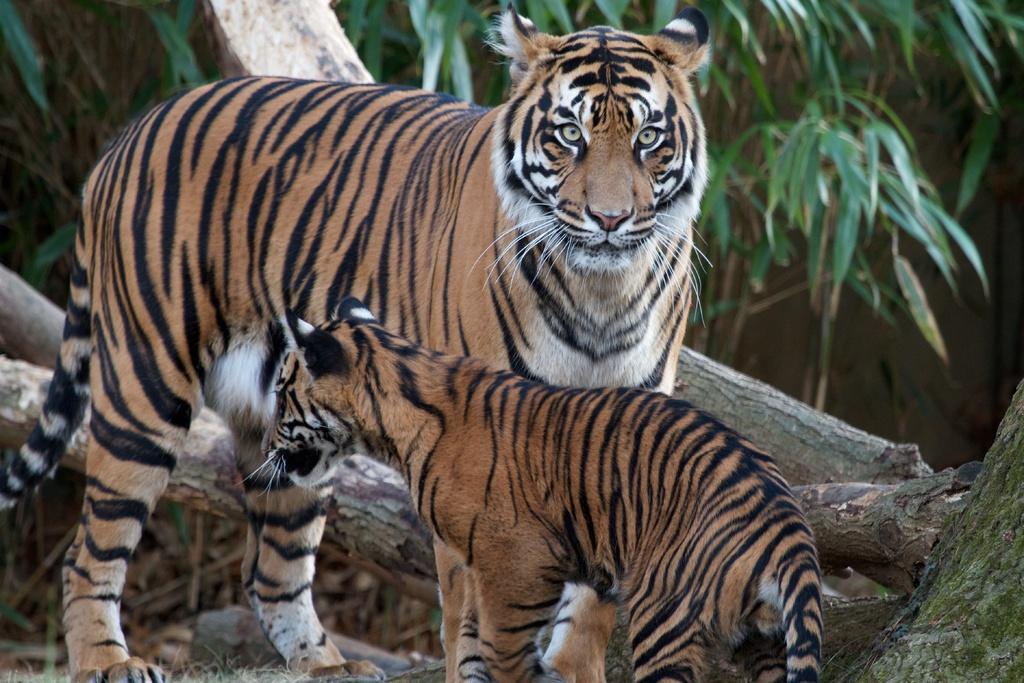Could you give a brief overview of what you see in this image? In this picture, we see a tiger and a cub. The tiger is looking at the camera. Behind that, we see the stem of the trees or the wooden sticks. There are trees in the background. This picture might be clicked in a zoo. 